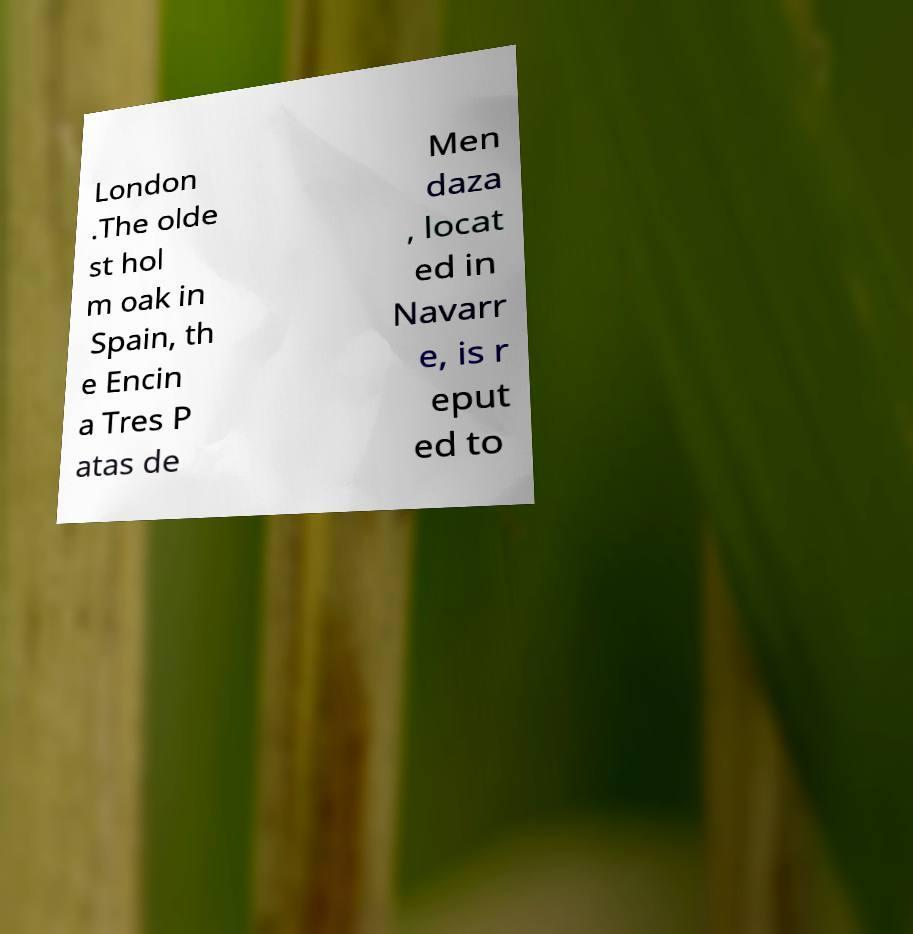I need the written content from this picture converted into text. Can you do that? London .The olde st hol m oak in Spain, th e Encin a Tres P atas de Men daza , locat ed in Navarr e, is r eput ed to 